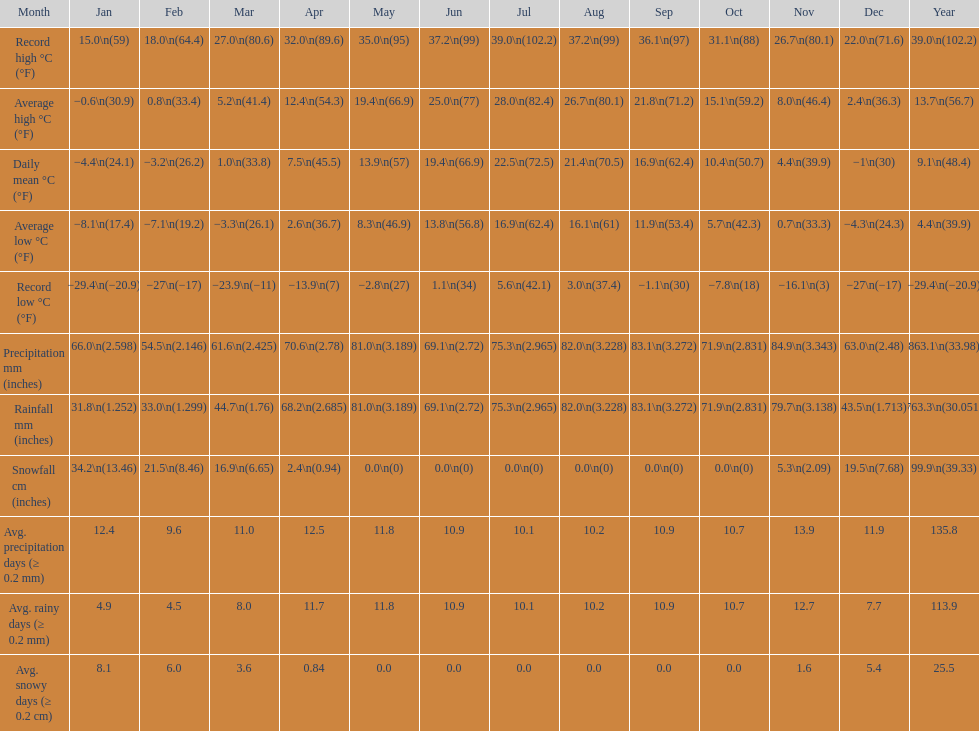Which month had an average high of 21.8 degrees and a record low of -1.1? September. 